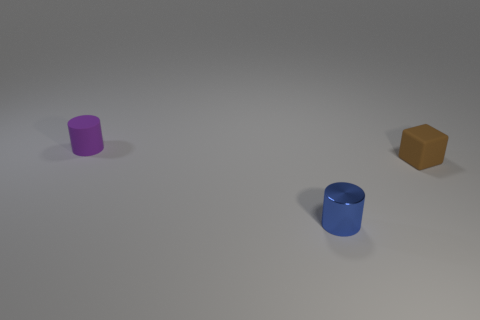Is there any other thing that is made of the same material as the brown thing?
Give a very brief answer. Yes. There is a rubber cylinder; are there any small matte objects left of it?
Ensure brevity in your answer.  No. How many tiny yellow metal blocks are there?
Your answer should be compact. 0. There is a purple thing that is behind the tiny brown block; what number of purple matte objects are to the right of it?
Provide a short and direct response. 0. There is a tiny matte cube; is its color the same as the cylinder that is behind the brown rubber object?
Your answer should be compact. No. What number of other tiny shiny objects are the same shape as the purple object?
Offer a very short reply. 1. What is the material of the tiny purple cylinder that is behind the small brown thing?
Keep it short and to the point. Rubber. There is a small rubber thing that is on the right side of the purple cylinder; is its shape the same as the tiny blue shiny object?
Your response must be concise. No. Is there another gray shiny object that has the same size as the shiny thing?
Ensure brevity in your answer.  No. Do the purple object and the metallic thing that is to the right of the rubber cylinder have the same shape?
Keep it short and to the point. Yes. 